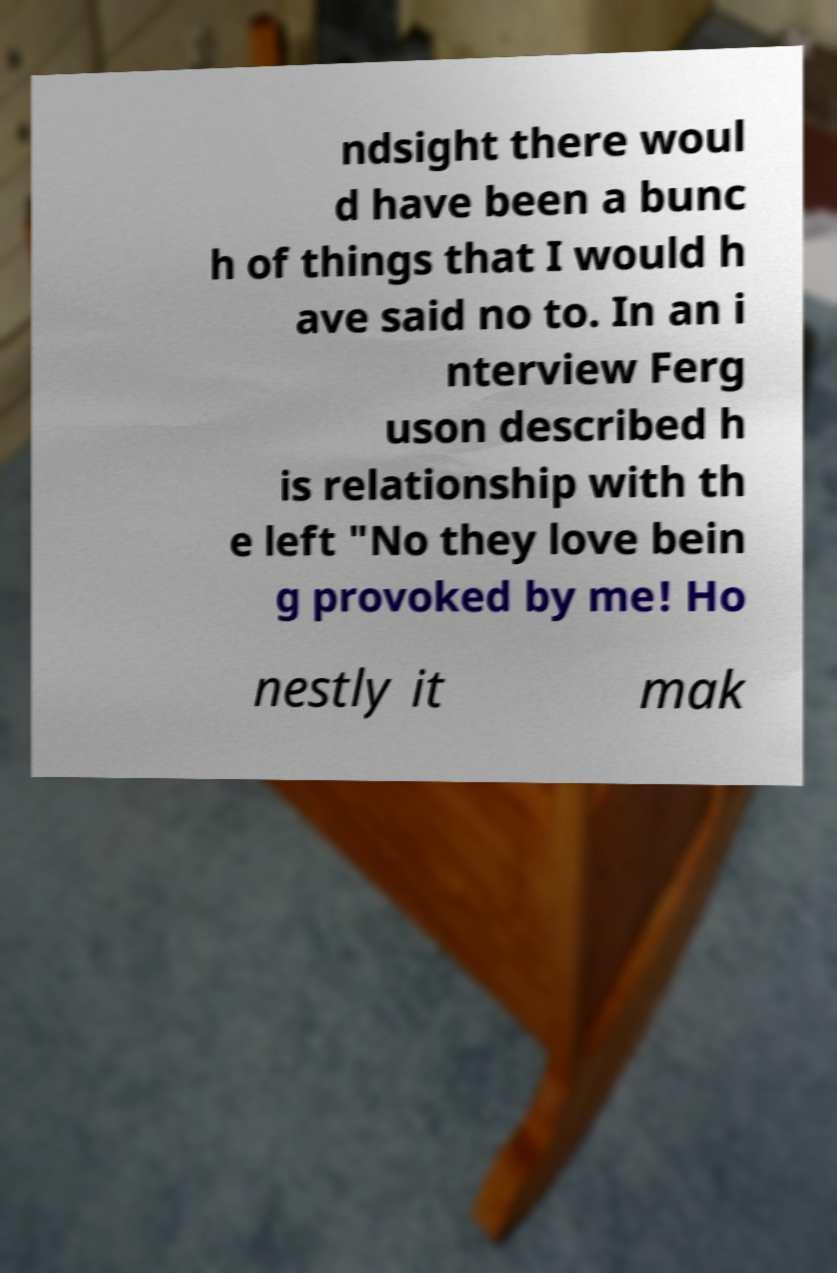For documentation purposes, I need the text within this image transcribed. Could you provide that? ndsight there woul d have been a bunc h of things that I would h ave said no to. In an i nterview Ferg uson described h is relationship with th e left "No they love bein g provoked by me! Ho nestly it mak 